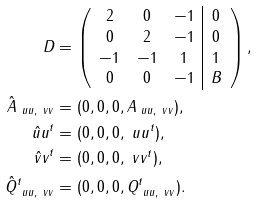Convert formula to latex. <formula><loc_0><loc_0><loc_500><loc_500>D & = \left ( \begin{array} { c c c | c c } 2 & 0 & - 1 & 0 \\ 0 & 2 & - 1 & 0 \\ - 1 & - 1 & 1 & 1 \\ 0 & 0 & - 1 & B \\ \end{array} \right ) , \\ \hat { A } _ { \ u u , \ v v } & = ( 0 , 0 , 0 , A _ { \ u u , \ v v } ) , \\ \hat { \ u u } ^ { t } & = ( 0 , 0 , 0 , \ u u ^ { t } ) , \\ \hat { \ v v } ^ { t } & = ( 0 , 0 , 0 , \ v v ^ { t } ) , \\ \hat { Q } ^ { t } _ { \ u u , \ v v } & = ( 0 , 0 , 0 , Q _ { \ u u , \ v v } ^ { t } ) .</formula> 